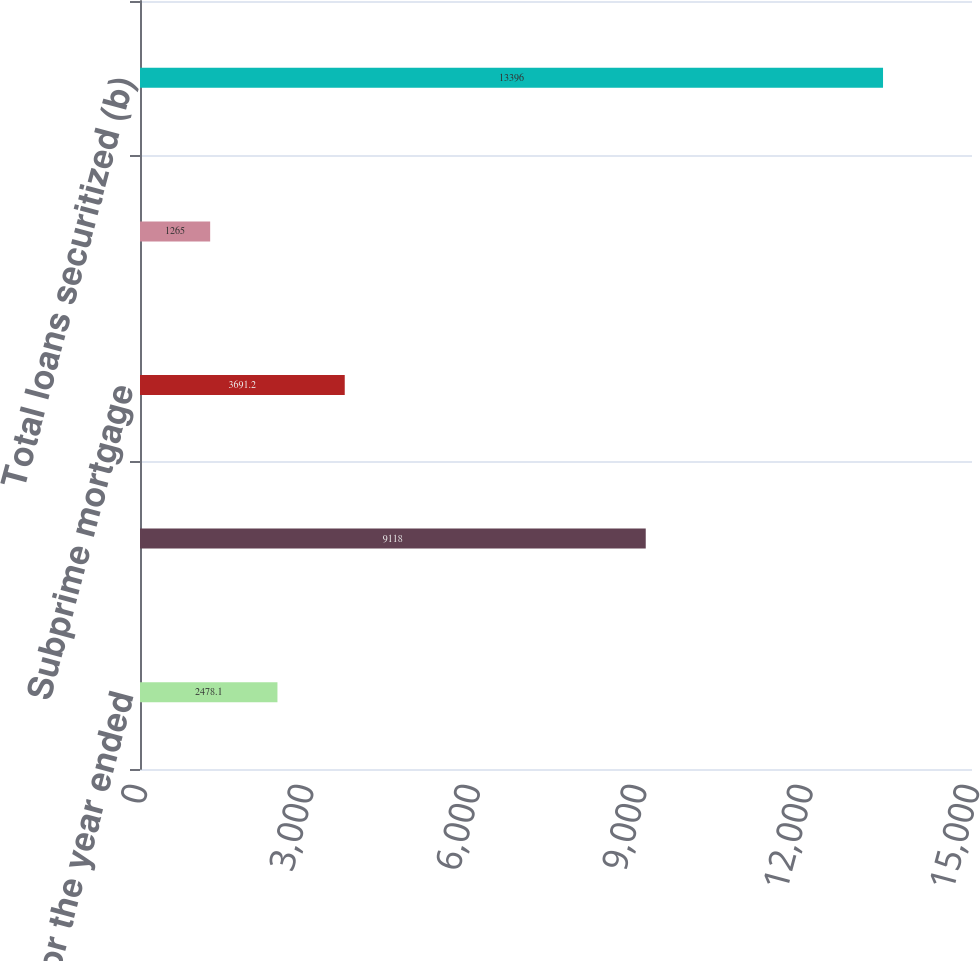<chart> <loc_0><loc_0><loc_500><loc_500><bar_chart><fcel>As of or for the year ended<fcel>Prime/ Alt-A & Option ARMs<fcel>Subprime mortgage<fcel>Commercial and other<fcel>Total loans securitized (b)<nl><fcel>2478.1<fcel>9118<fcel>3691.2<fcel>1265<fcel>13396<nl></chart> 